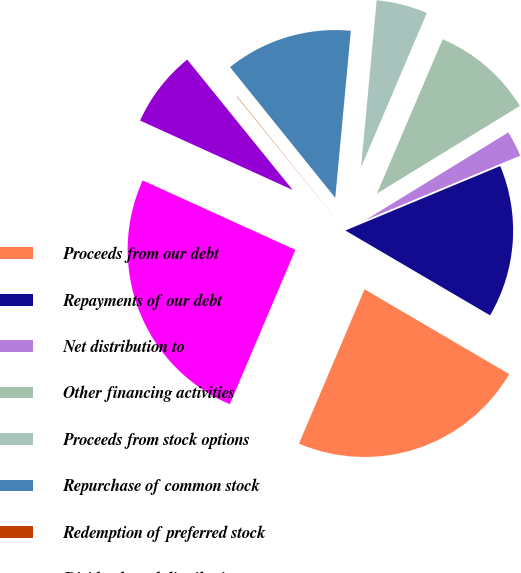Convert chart to OTSL. <chart><loc_0><loc_0><loc_500><loc_500><pie_chart><fcel>Proceeds from our debt<fcel>Repayments of our debt<fcel>Net distribution to<fcel>Other financing activities<fcel>Proceeds from stock options<fcel>Repurchase of common stock<fcel>Redemption of preferred stock<fcel>Dividends and distributions<fcel>Increase in net cash provided<nl><fcel>22.95%<fcel>14.72%<fcel>2.48%<fcel>9.83%<fcel>4.93%<fcel>12.27%<fcel>0.04%<fcel>7.38%<fcel>25.4%<nl></chart> 